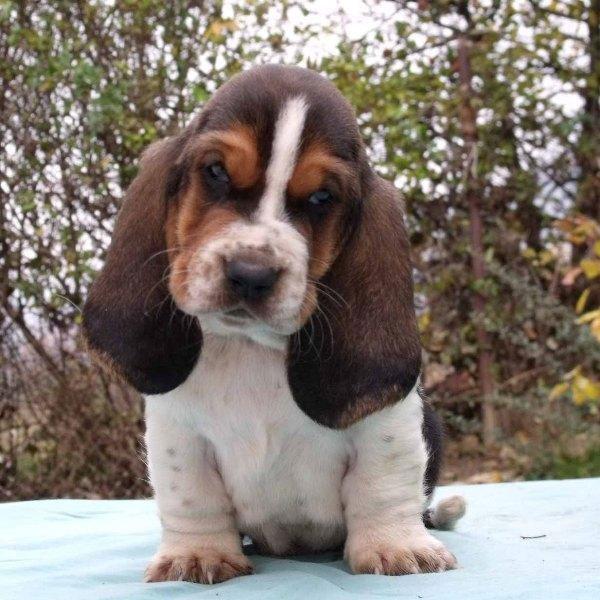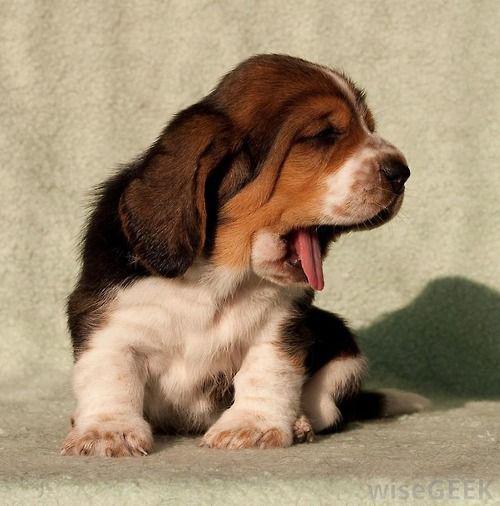The first image is the image on the left, the second image is the image on the right. Assess this claim about the two images: "There is a small puppy with brown floppy ears sitting on white snow.". Correct or not? Answer yes or no. Yes. The first image is the image on the left, the second image is the image on the right. For the images displayed, is the sentence "Each image shows a basset hound, and the hound on the right looks sleepy-eyed." factually correct? Answer yes or no. Yes. 